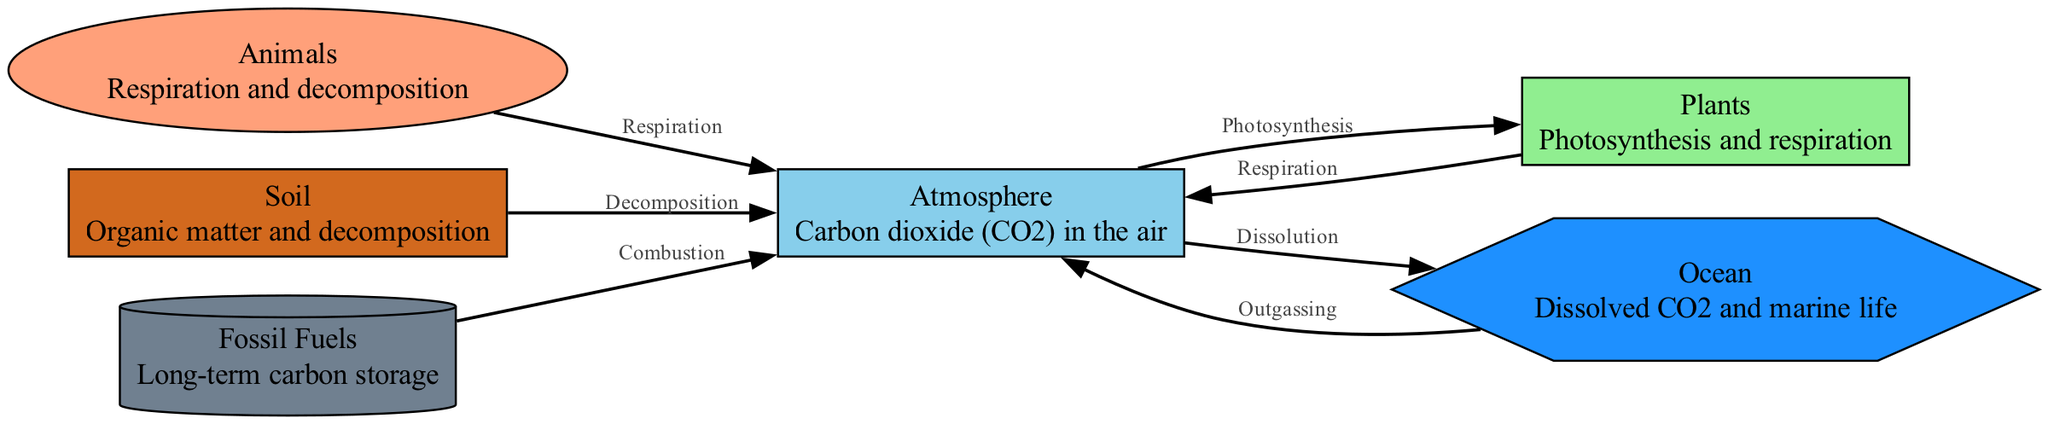What is the main greenhouse gas depicted in this diagram? The node labeled "Atmosphere" identifies carbon dioxide (CO2) as the main greenhouse gas present in the air.
Answer: carbon dioxide How many nodes are present in the carbon cycle diagram? The diagram includes six distinct nodes: atmosphere, plants, animals, soil, ocean, and fossil fuels. Hence, the total is 6.
Answer: 6 What relationship connects animals to the atmosphere? The edge labeled "Respiration" demonstrates the flow of carbon dioxide from animals back to the atmosphere through the process of respiration.
Answer: Respiration Which node contributes carbon to the atmosphere through combustion? The node "Fossil Fuels" indicates that the process of combustion releases carbon into the atmosphere.
Answer: Fossil Fuels What process allows CO2 to move from the ocean to the atmosphere? The edge labeled "Outgassing" represents the movement of carbon dioxide from the ocean into the atmosphere.
Answer: Outgassing How do plants extract carbon from the atmosphere? The process illustrated by the edge labeled "Photosynthesis" indicates that plants absorb carbon dioxide from the atmosphere for photosynthesis.
Answer: Photosynthesis What is the final destination of carbon following its decomposition by soil? The edge labeled "Decomposition" shows that carbon returns to the atmosphere after being released from soil.
Answer: Atmosphere Which node is depicted as a long-term carbon storage? The diagram identifies the "Fossil Fuels" node as the location for long-term carbon storage in the carbon cycle.
Answer: Fossil Fuels How does the ocean receive carbon? The node is connected to the atmosphere through the edge labeled "Dissolution," which indicates that carbon dioxide dissolves into ocean water from the atmosphere.
Answer: Dissolution 